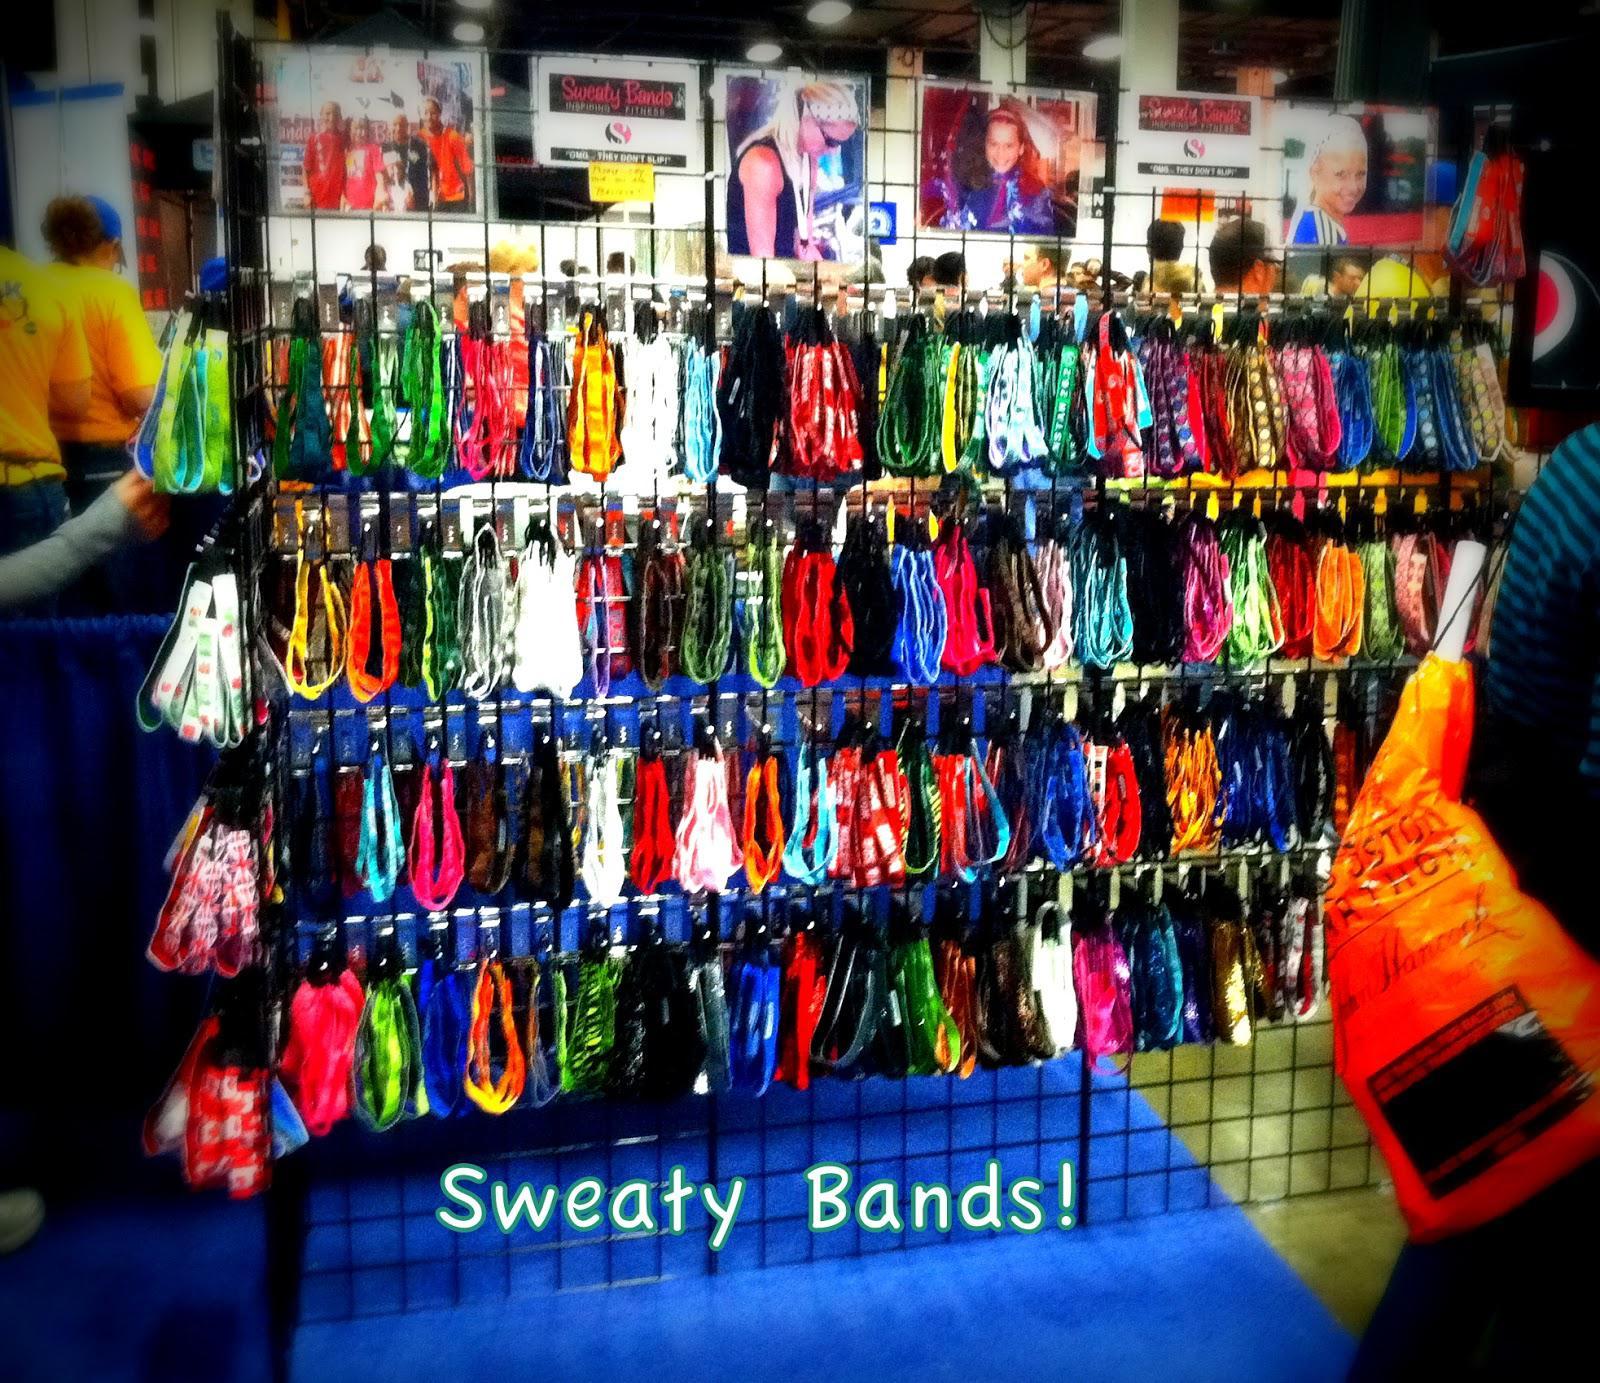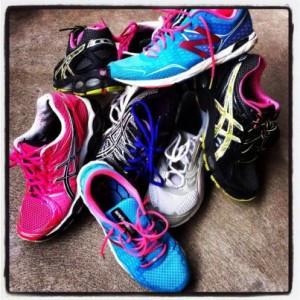The first image is the image on the left, the second image is the image on the right. Examine the images to the left and right. Is the description "One image shows several pairs of shoes lined up neatly on the floor." accurate? Answer yes or no. No. 